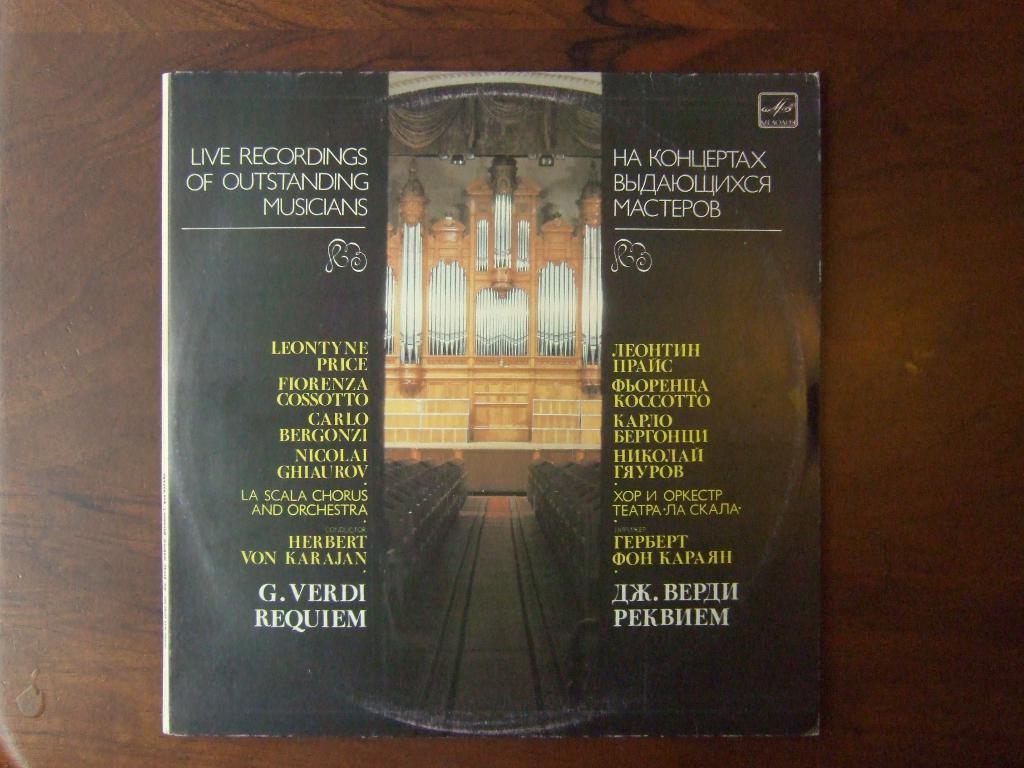Who is the composer on this record?
Provide a short and direct response. Unanswerable. What is the title of this album?
Ensure brevity in your answer.  Live recordings of outstanding musicians. 